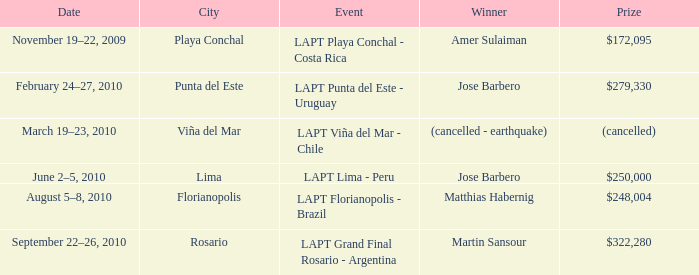What event has a $248,004 prize? LAPT Florianopolis - Brazil. 